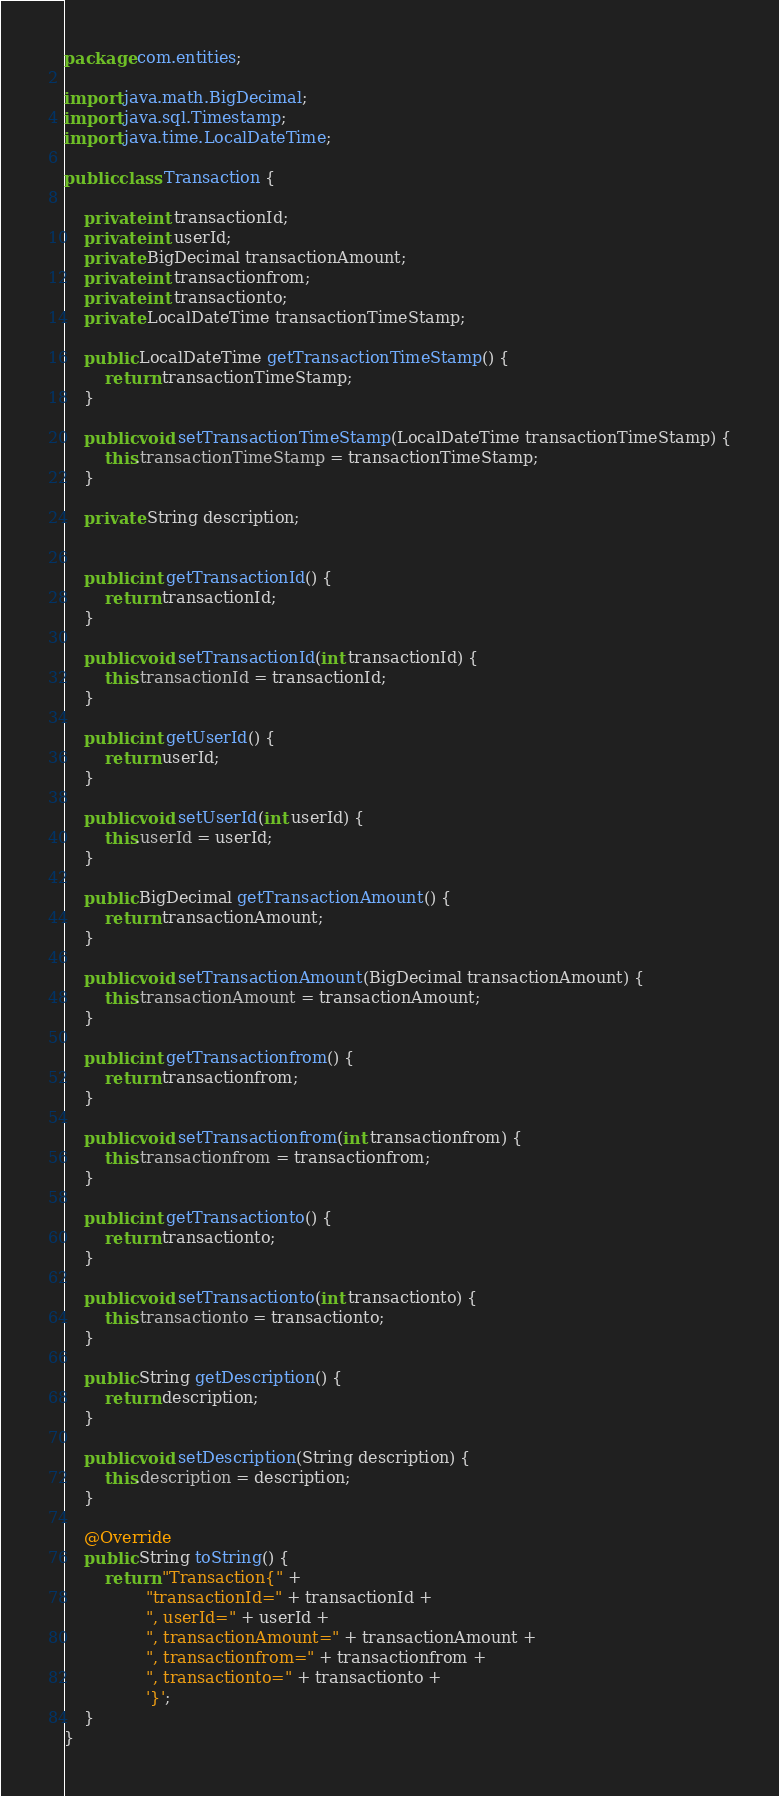Convert code to text. <code><loc_0><loc_0><loc_500><loc_500><_Java_>package com.entities;

import java.math.BigDecimal;
import java.sql.Timestamp;
import java.time.LocalDateTime;

public class Transaction {

    private int transactionId;
    private int userId;
    private BigDecimal transactionAmount;
    private int transactionfrom;
    private int transactionto;
    private LocalDateTime transactionTimeStamp;

    public LocalDateTime getTransactionTimeStamp() {
        return transactionTimeStamp;
    }

    public void setTransactionTimeStamp(LocalDateTime transactionTimeStamp) {
        this.transactionTimeStamp = transactionTimeStamp;
    }

    private String description;


    public int getTransactionId() {
        return transactionId;
    }

    public void setTransactionId(int transactionId) {
        this.transactionId = transactionId;
    }

    public int getUserId() {
        return userId;
    }

    public void setUserId(int userId) {
        this.userId = userId;
    }

    public BigDecimal getTransactionAmount() {
        return transactionAmount;
    }

    public void setTransactionAmount(BigDecimal transactionAmount) {
        this.transactionAmount = transactionAmount;
    }

    public int getTransactionfrom() {
        return transactionfrom;
    }

    public void setTransactionfrom(int transactionfrom) {
        this.transactionfrom = transactionfrom;
    }

    public int getTransactionto() {
        return transactionto;
    }

    public void setTransactionto(int transactionto) {
        this.transactionto = transactionto;
    }

    public String getDescription() {
        return description;
    }

    public void setDescription(String description) {
        this.description = description;
    }

    @Override
    public String toString() {
        return "Transaction{" +
                "transactionId=" + transactionId +
                ", userId=" + userId +
                ", transactionAmount=" + transactionAmount +
                ", transactionfrom=" + transactionfrom +
                ", transactionto=" + transactionto +
                '}';
    }
}
</code> 